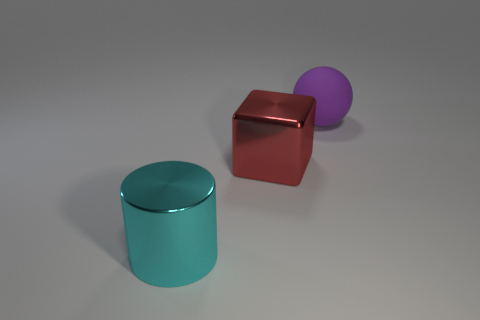Are there any other things that have the same shape as the red metal object?
Ensure brevity in your answer.  No. What number of small objects are either cyan metal cylinders or red things?
Ensure brevity in your answer.  0. The ball has what color?
Your answer should be compact. Purple. What is the shape of the metal object on the left side of the large metal thing that is on the right side of the large shiny cylinder?
Your answer should be very brief. Cylinder. Is there a large block that has the same material as the cylinder?
Provide a short and direct response. Yes. There is a thing that is behind the red metallic thing; is its size the same as the big cyan metallic cylinder?
Your answer should be very brief. Yes. What number of cyan things are big things or rubber things?
Offer a terse response. 1. What material is the thing that is in front of the metal cube?
Your response must be concise. Metal. What number of large metal objects are behind the object that is in front of the large red metallic block?
Your response must be concise. 1. How many large red metal objects are the same shape as the purple object?
Your answer should be very brief. 0. 